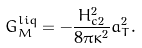Convert formula to latex. <formula><loc_0><loc_0><loc_500><loc_500>G _ { M } ^ { l i q } = - \frac { H _ { c 2 } ^ { 2 } } { 8 \pi \kappa ^ { 2 } } a _ { T } ^ { 2 } .</formula> 